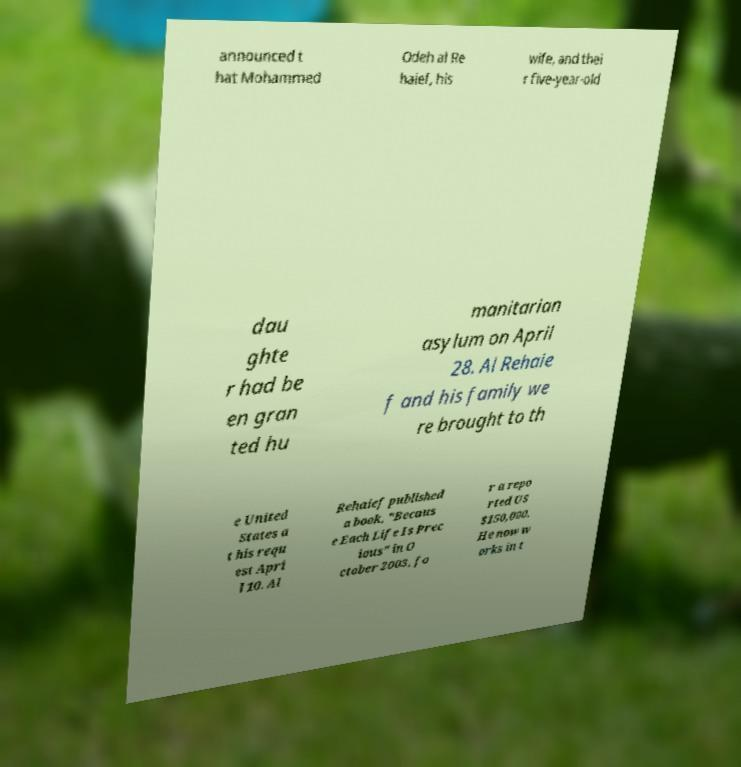For documentation purposes, I need the text within this image transcribed. Could you provide that? announced t hat Mohammed Odeh al Re haief, his wife, and thei r five-year-old dau ghte r had be en gran ted hu manitarian asylum on April 28. Al Rehaie f and his family we re brought to th e United States a t his requ est Apri l 10. Al Rehaief published a book, "Becaus e Each Life Is Prec ious" in O ctober 2003, fo r a repo rted US $150,000. He now w orks in t 